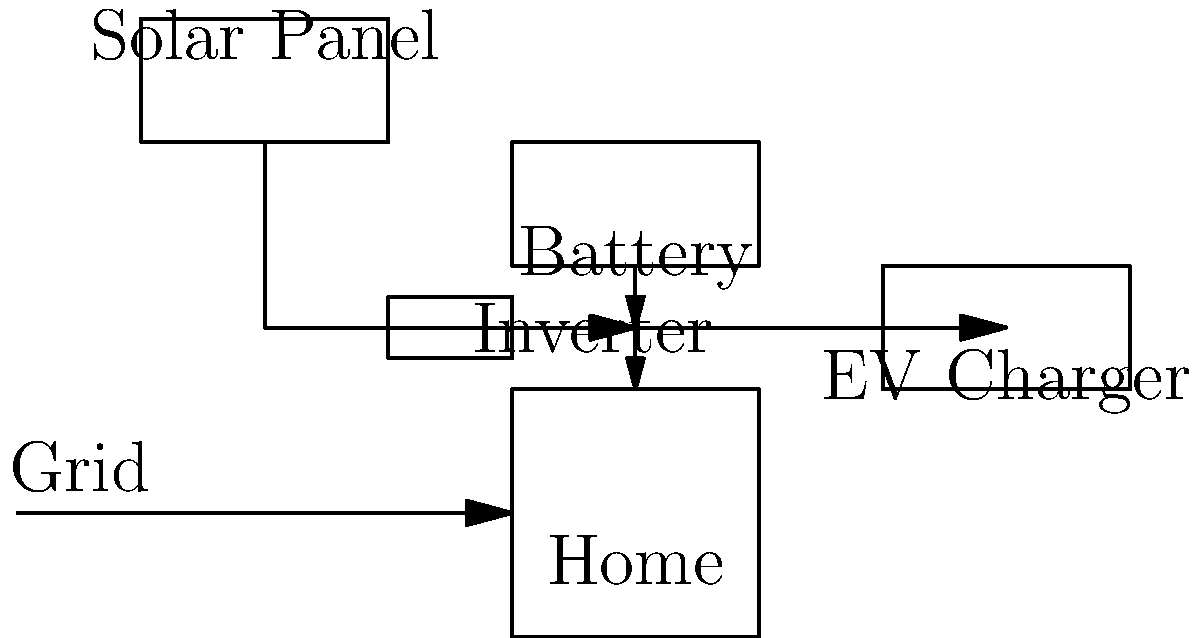In the home energy management system shown above, what component is crucial for converting DC power from solar panels and batteries to AC power for home use and grid integration? To answer this question, let's analyze the components and their roles in the home energy management system:

1. Solar Panel: Generates DC (Direct Current) electricity from sunlight.
2. Battery: Stores excess energy in DC form.
3. EV Charger: Typically requires DC power for charging electric vehicles.
4. Home: Requires AC (Alternating Current) power for most appliances.
5. Grid: Operates on AC power.

The key component that bridges the gap between DC and AC power in this system is the inverter. Here's why:

1. Solar panels and batteries produce and store DC power.
2. The home and grid operate on AC power.
3. To use the power from solar panels and batteries in the home or feed it back to the grid, it must be converted from DC to AC.
4. The inverter performs this crucial conversion, allowing DC power from renewable sources to be used in AC applications.

Without the inverter, the DC power from solar panels and batteries couldn't be efficiently used in the home or integrated with the grid, which are predominantly AC systems.
Answer: Inverter 